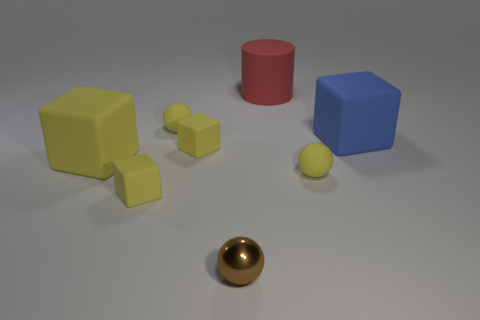Are there more matte spheres than small red metal objects?
Offer a terse response. Yes. What number of things are small yellow balls right of the big red cylinder or big red matte things?
Offer a very short reply. 2. How many small yellow balls are behind the tiny yellow sphere to the right of the tiny brown ball?
Provide a succinct answer. 1. How big is the red cylinder to the right of the block in front of the tiny rubber ball that is in front of the big yellow matte object?
Your answer should be compact. Large. There is a matte ball that is in front of the big yellow rubber block; is its color the same as the tiny metal ball?
Ensure brevity in your answer.  No. The blue object that is the same shape as the big yellow object is what size?
Your answer should be very brief. Large. What number of things are either small rubber objects to the left of the cylinder or balls that are to the right of the brown shiny thing?
Keep it short and to the point. 4. What shape is the object that is in front of the small rubber cube that is in front of the large yellow matte block?
Provide a short and direct response. Sphere. Are there any other things that are the same color as the large cylinder?
Ensure brevity in your answer.  No. Is there anything else that has the same size as the metal ball?
Provide a short and direct response. Yes. 